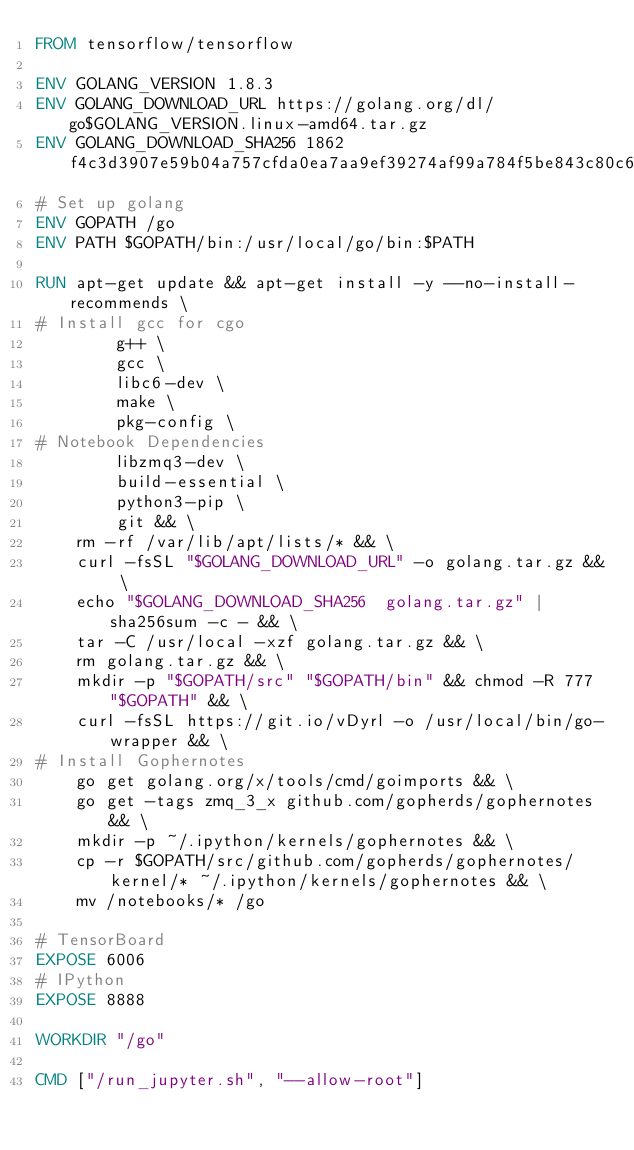Convert code to text. <code><loc_0><loc_0><loc_500><loc_500><_Dockerfile_>FROM tensorflow/tensorflow

ENV GOLANG_VERSION 1.8.3
ENV GOLANG_DOWNLOAD_URL https://golang.org/dl/go$GOLANG_VERSION.linux-amd64.tar.gz
ENV GOLANG_DOWNLOAD_SHA256 1862f4c3d3907e59b04a757cfda0ea7aa9ef39274af99a784f5be843c80c6772
# Set up golang
ENV GOPATH /go
ENV PATH $GOPATH/bin:/usr/local/go/bin:$PATH

RUN apt-get update && apt-get install -y --no-install-recommends \
# Install gcc for cgo
        g++ \
        gcc \
        libc6-dev \
        make \
        pkg-config \
# Notebook Dependencies
        libzmq3-dev \
        build-essential \
        python3-pip \
        git && \
    rm -rf /var/lib/apt/lists/* && \
    curl -fsSL "$GOLANG_DOWNLOAD_URL" -o golang.tar.gz && \
    echo "$GOLANG_DOWNLOAD_SHA256  golang.tar.gz" | sha256sum -c - && \
    tar -C /usr/local -xzf golang.tar.gz && \
    rm golang.tar.gz && \
    mkdir -p "$GOPATH/src" "$GOPATH/bin" && chmod -R 777 "$GOPATH" && \
    curl -fsSL https://git.io/vDyrl -o /usr/local/bin/go-wrapper && \
# Install Gophernotes
    go get golang.org/x/tools/cmd/goimports && \
    go get -tags zmq_3_x github.com/gopherds/gophernotes && \
    mkdir -p ~/.ipython/kernels/gophernotes && \
    cp -r $GOPATH/src/github.com/gopherds/gophernotes/kernel/* ~/.ipython/kernels/gophernotes && \
    mv /notebooks/* /go

# TensorBoard
EXPOSE 6006
# IPython
EXPOSE 8888

WORKDIR "/go"

CMD ["/run_jupyter.sh", "--allow-root"]
</code> 